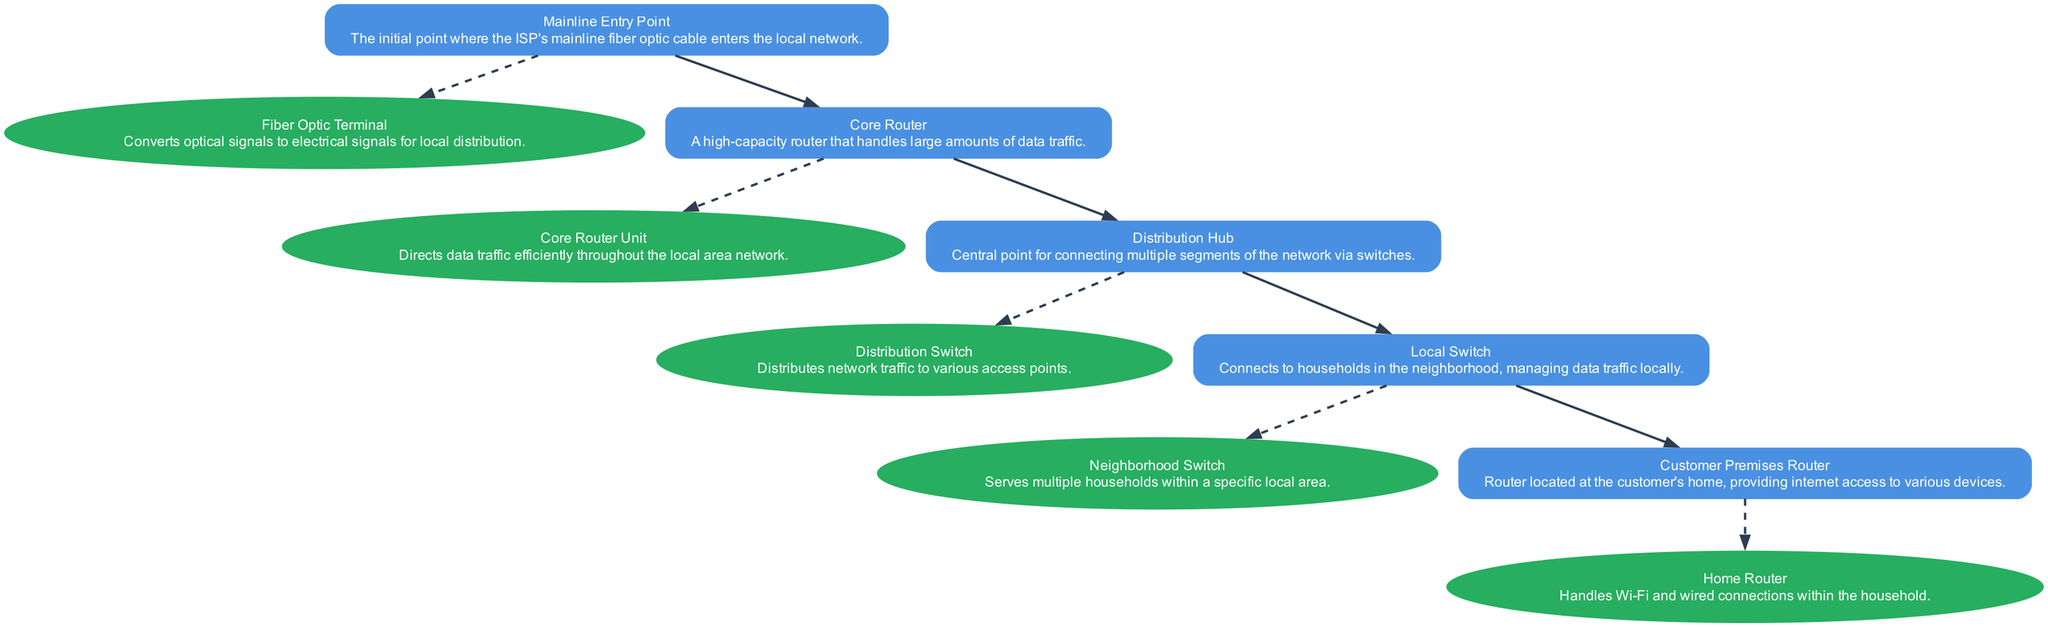What is the first point in the network? The first point in the network is labeled as the "Mainline Entry Point," which is where the ISP's mainline fiber optic cable enters the local network.
Answer: Mainline Entry Point How many switches are present in the infrastructure? There are two switches: the "Distribution Switch" and the "Neighborhood Switch," which are each connected to different segments of the network.
Answer: Two switches What device converts optical signals to electrical signals? The device responsible for converting optical signals to electrical signals at the mainline entry point is called the "Fiber Optic Terminal."
Answer: Fiber Optic Terminal Which device is responsible for handling data traffic efficiently? The "Core Router Unit" is responsible for directing data traffic efficiently throughout the local area network.
Answer: Core Router Unit What is the last component that connects to customer households? The last component in the diagram that connects to customer households is the "Customer Premises Router."
Answer: Customer Premises Router What connects the Distribution Hub to the Local Switch? The connection from the "Distribution Hub" to the "Local Switch" is made directly, indicating that the hub distributes traffic to the switch.
Answer: Distribution Hub Which device serves multiple households? The device that serves multiple households within a specific local area is the "Neighborhood Switch."
Answer: Neighborhood Switch How many edges connect the Core Router to other components? The "Core Router" connects to two components: the "Mainline Entry Point" and the "Distribution Hub," resulting in two edges.
Answer: Two edges What does the Local Switch primarily manage? The "Local Switch" primarily manages data traffic locally, connecting to various customer households in the neighborhood.
Answer: Data traffic locally 